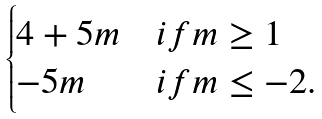Convert formula to latex. <formula><loc_0><loc_0><loc_500><loc_500>\begin{cases} 4 + 5 m & i f m \geq 1 \\ - 5 m & i f m \leq - 2 . \end{cases}</formula> 